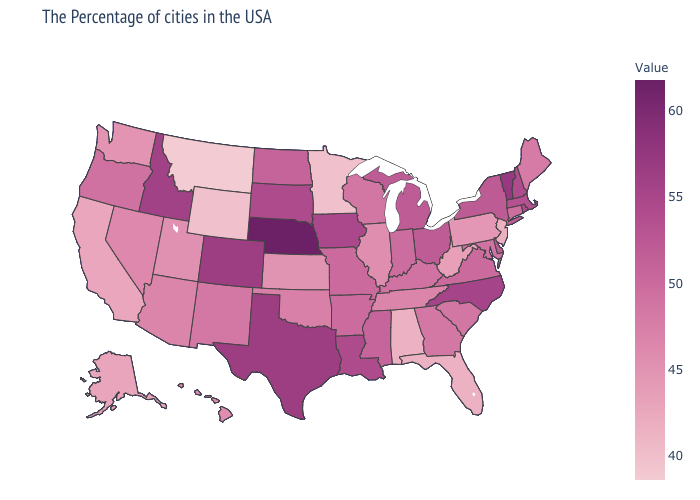Does Indiana have the lowest value in the USA?
Short answer required. No. Does South Carolina have the highest value in the USA?
Short answer required. No. Is the legend a continuous bar?
Give a very brief answer. Yes. Among the states that border Delaware , does Maryland have the lowest value?
Answer briefly. No. Does Delaware have the lowest value in the South?
Short answer required. No. 